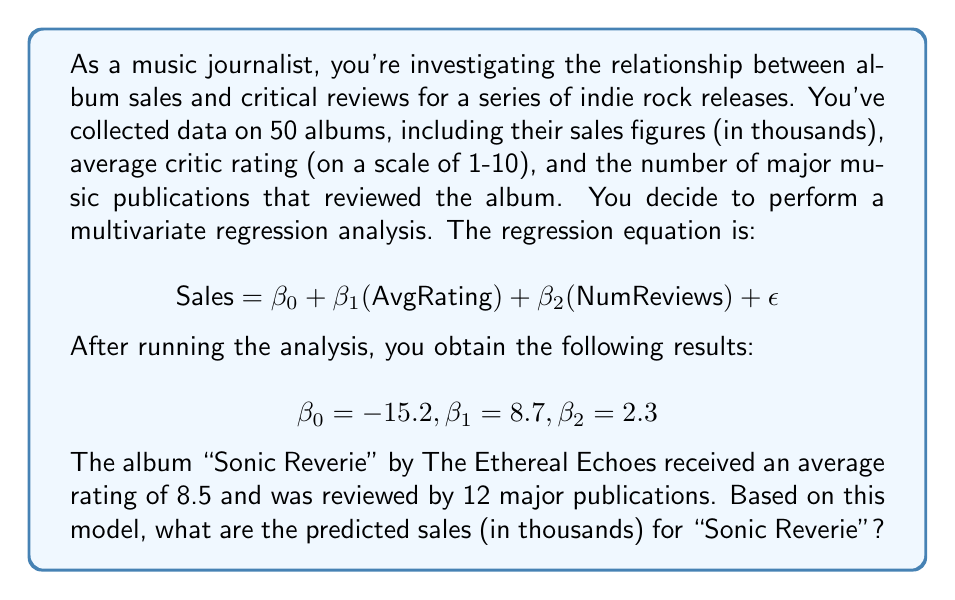Give your solution to this math problem. To solve this problem, we need to use the multivariate regression equation provided and plug in the values we know. Let's break it down step-by-step:

1. The regression equation is:
   $$ \text{Sales} = \beta_0 + \beta_1(\text{AvgRating}) + \beta_2(\text{NumReviews}) + \epsilon $$

2. We're given the following coefficients:
   $$ \beta_0 = -15.2, \beta_1 = 8.7, \beta_2 = 2.3 $$

3. For the album "Sonic Reverie," we have:
   - Average Rating (AvgRating) = 8.5
   - Number of Reviews (NumReviews) = 12

4. Let's substitute these values into our equation:
   $$ \text{Sales} = -15.2 + 8.7(\text{AvgRating}) + 2.3(\text{NumReviews}) $$
   $$ \text{Sales} = -15.2 + 8.7(8.5) + 2.3(12) $$

5. Now, let's calculate each term:
   - $8.7(8.5) = 73.95$
   - $2.3(12) = 27.6$

6. Putting it all together:
   $$ \text{Sales} = -15.2 + 73.95 + 27.6 $$
   $$ \text{Sales} = 86.35 $$

7. Since sales are in thousands, this means 86,350 units.

Note: We ignore the error term $\epsilon$ in our prediction as it represents the random variation not accounted for by the model.
Answer: The predicted sales for "Sonic Reverie" by The Ethereal Echoes are 86.35 thousand units, or 86,350 albums. 